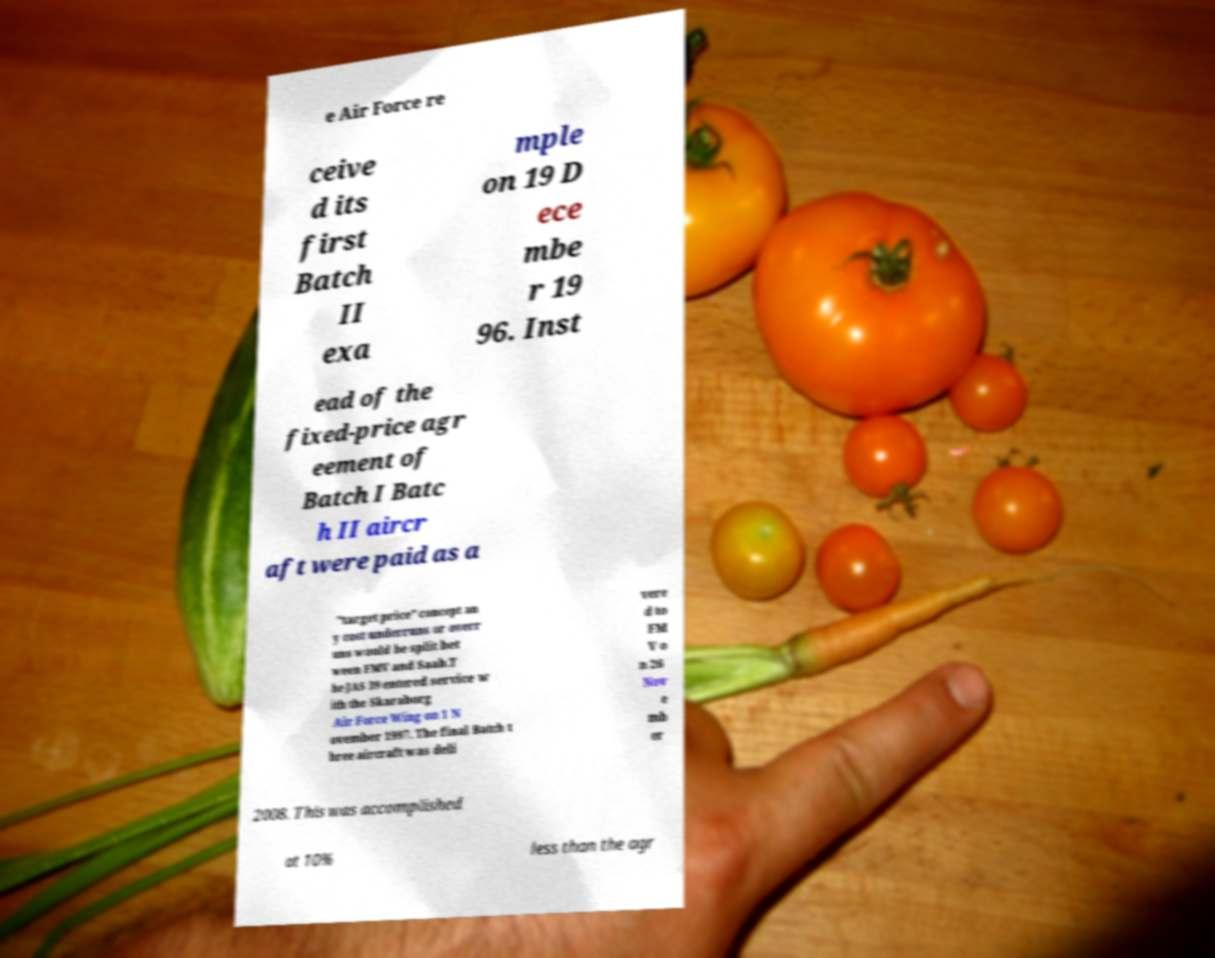Please read and relay the text visible in this image. What does it say? e Air Force re ceive d its first Batch II exa mple on 19 D ece mbe r 19 96. Inst ead of the fixed-price agr eement of Batch I Batc h II aircr aft were paid as a "target price" concept an y cost underruns or overr uns would be split bet ween FMV and Saab.T he JAS 39 entered service w ith the Skaraborg Air Force Wing on 1 N ovember 1997. The final Batch t hree aircraft was deli vere d to FM V o n 26 Nov e mb er 2008. This was accomplished at 10% less than the agr 